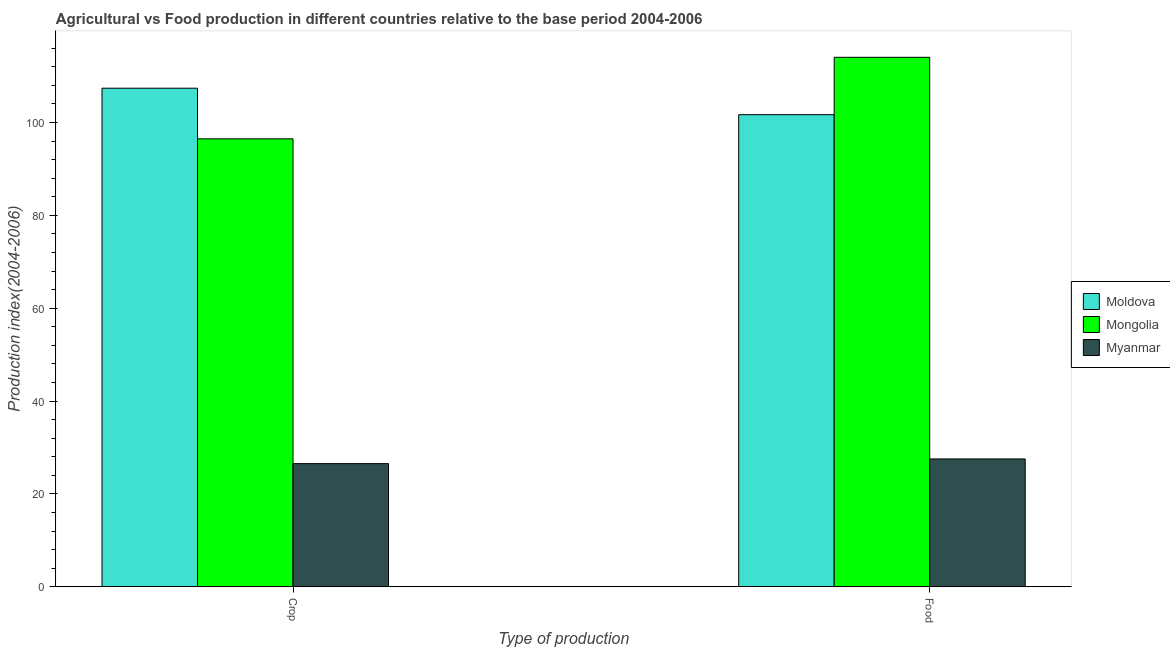Are the number of bars per tick equal to the number of legend labels?
Provide a short and direct response. Yes. Are the number of bars on each tick of the X-axis equal?
Your answer should be compact. Yes. What is the label of the 1st group of bars from the left?
Give a very brief answer. Crop. What is the crop production index in Myanmar?
Your answer should be compact. 26.52. Across all countries, what is the maximum crop production index?
Offer a very short reply. 107.38. Across all countries, what is the minimum food production index?
Your answer should be compact. 27.53. In which country was the crop production index maximum?
Offer a very short reply. Moldova. In which country was the crop production index minimum?
Ensure brevity in your answer.  Myanmar. What is the total food production index in the graph?
Your answer should be very brief. 243.25. What is the difference between the food production index in Myanmar and that in Moldova?
Make the answer very short. -74.15. What is the difference between the crop production index in Moldova and the food production index in Mongolia?
Your response must be concise. -6.66. What is the average crop production index per country?
Provide a short and direct response. 76.79. What is the difference between the food production index and crop production index in Mongolia?
Offer a terse response. 17.56. In how many countries, is the food production index greater than 64 ?
Your response must be concise. 2. What is the ratio of the crop production index in Myanmar to that in Moldova?
Provide a succinct answer. 0.25. In how many countries, is the food production index greater than the average food production index taken over all countries?
Your response must be concise. 2. What does the 1st bar from the left in Crop represents?
Provide a succinct answer. Moldova. What does the 3rd bar from the right in Food represents?
Give a very brief answer. Moldova. Are all the bars in the graph horizontal?
Your response must be concise. No. What is the difference between two consecutive major ticks on the Y-axis?
Make the answer very short. 20. Are the values on the major ticks of Y-axis written in scientific E-notation?
Keep it short and to the point. No. Does the graph contain any zero values?
Give a very brief answer. No. How many legend labels are there?
Offer a terse response. 3. How are the legend labels stacked?
Your answer should be compact. Vertical. What is the title of the graph?
Make the answer very short. Agricultural vs Food production in different countries relative to the base period 2004-2006. What is the label or title of the X-axis?
Your answer should be compact. Type of production. What is the label or title of the Y-axis?
Your response must be concise. Production index(2004-2006). What is the Production index(2004-2006) in Moldova in Crop?
Your answer should be very brief. 107.38. What is the Production index(2004-2006) in Mongolia in Crop?
Your response must be concise. 96.48. What is the Production index(2004-2006) in Myanmar in Crop?
Provide a succinct answer. 26.52. What is the Production index(2004-2006) of Moldova in Food?
Offer a very short reply. 101.68. What is the Production index(2004-2006) of Mongolia in Food?
Provide a short and direct response. 114.04. What is the Production index(2004-2006) in Myanmar in Food?
Provide a succinct answer. 27.53. Across all Type of production, what is the maximum Production index(2004-2006) in Moldova?
Provide a succinct answer. 107.38. Across all Type of production, what is the maximum Production index(2004-2006) of Mongolia?
Ensure brevity in your answer.  114.04. Across all Type of production, what is the maximum Production index(2004-2006) of Myanmar?
Your answer should be compact. 27.53. Across all Type of production, what is the minimum Production index(2004-2006) in Moldova?
Keep it short and to the point. 101.68. Across all Type of production, what is the minimum Production index(2004-2006) in Mongolia?
Your response must be concise. 96.48. Across all Type of production, what is the minimum Production index(2004-2006) of Myanmar?
Provide a succinct answer. 26.52. What is the total Production index(2004-2006) of Moldova in the graph?
Your response must be concise. 209.06. What is the total Production index(2004-2006) of Mongolia in the graph?
Your answer should be very brief. 210.52. What is the total Production index(2004-2006) in Myanmar in the graph?
Give a very brief answer. 54.05. What is the difference between the Production index(2004-2006) of Moldova in Crop and that in Food?
Your answer should be compact. 5.7. What is the difference between the Production index(2004-2006) of Mongolia in Crop and that in Food?
Your answer should be compact. -17.56. What is the difference between the Production index(2004-2006) of Myanmar in Crop and that in Food?
Provide a short and direct response. -1.01. What is the difference between the Production index(2004-2006) of Moldova in Crop and the Production index(2004-2006) of Mongolia in Food?
Provide a short and direct response. -6.66. What is the difference between the Production index(2004-2006) of Moldova in Crop and the Production index(2004-2006) of Myanmar in Food?
Keep it short and to the point. 79.85. What is the difference between the Production index(2004-2006) of Mongolia in Crop and the Production index(2004-2006) of Myanmar in Food?
Ensure brevity in your answer.  68.95. What is the average Production index(2004-2006) of Moldova per Type of production?
Ensure brevity in your answer.  104.53. What is the average Production index(2004-2006) of Mongolia per Type of production?
Ensure brevity in your answer.  105.26. What is the average Production index(2004-2006) in Myanmar per Type of production?
Offer a terse response. 27.02. What is the difference between the Production index(2004-2006) in Moldova and Production index(2004-2006) in Myanmar in Crop?
Offer a terse response. 80.86. What is the difference between the Production index(2004-2006) in Mongolia and Production index(2004-2006) in Myanmar in Crop?
Give a very brief answer. 69.96. What is the difference between the Production index(2004-2006) of Moldova and Production index(2004-2006) of Mongolia in Food?
Your answer should be compact. -12.36. What is the difference between the Production index(2004-2006) of Moldova and Production index(2004-2006) of Myanmar in Food?
Make the answer very short. 74.15. What is the difference between the Production index(2004-2006) in Mongolia and Production index(2004-2006) in Myanmar in Food?
Ensure brevity in your answer.  86.51. What is the ratio of the Production index(2004-2006) in Moldova in Crop to that in Food?
Your answer should be compact. 1.06. What is the ratio of the Production index(2004-2006) of Mongolia in Crop to that in Food?
Provide a short and direct response. 0.85. What is the ratio of the Production index(2004-2006) in Myanmar in Crop to that in Food?
Provide a short and direct response. 0.96. What is the difference between the highest and the second highest Production index(2004-2006) in Moldova?
Ensure brevity in your answer.  5.7. What is the difference between the highest and the second highest Production index(2004-2006) of Mongolia?
Give a very brief answer. 17.56. What is the difference between the highest and the second highest Production index(2004-2006) of Myanmar?
Provide a short and direct response. 1.01. What is the difference between the highest and the lowest Production index(2004-2006) of Mongolia?
Keep it short and to the point. 17.56. What is the difference between the highest and the lowest Production index(2004-2006) of Myanmar?
Ensure brevity in your answer.  1.01. 